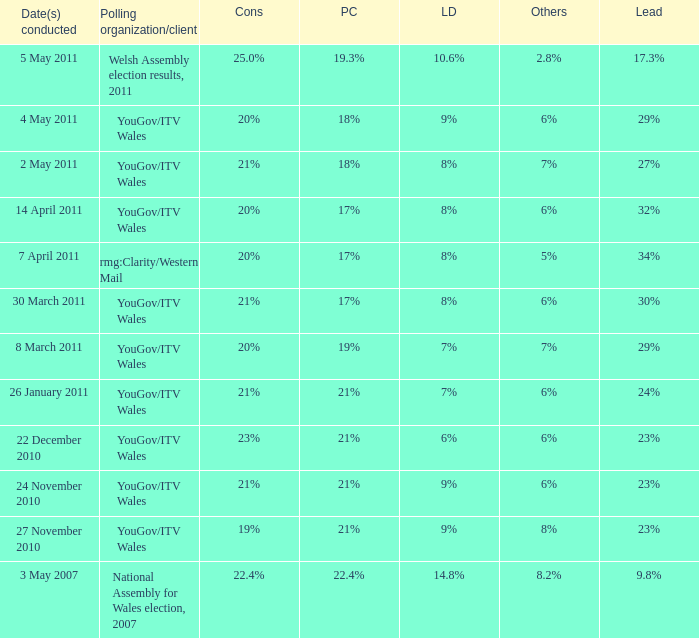I want the plaid cymru for 4 may 2011 18%. 